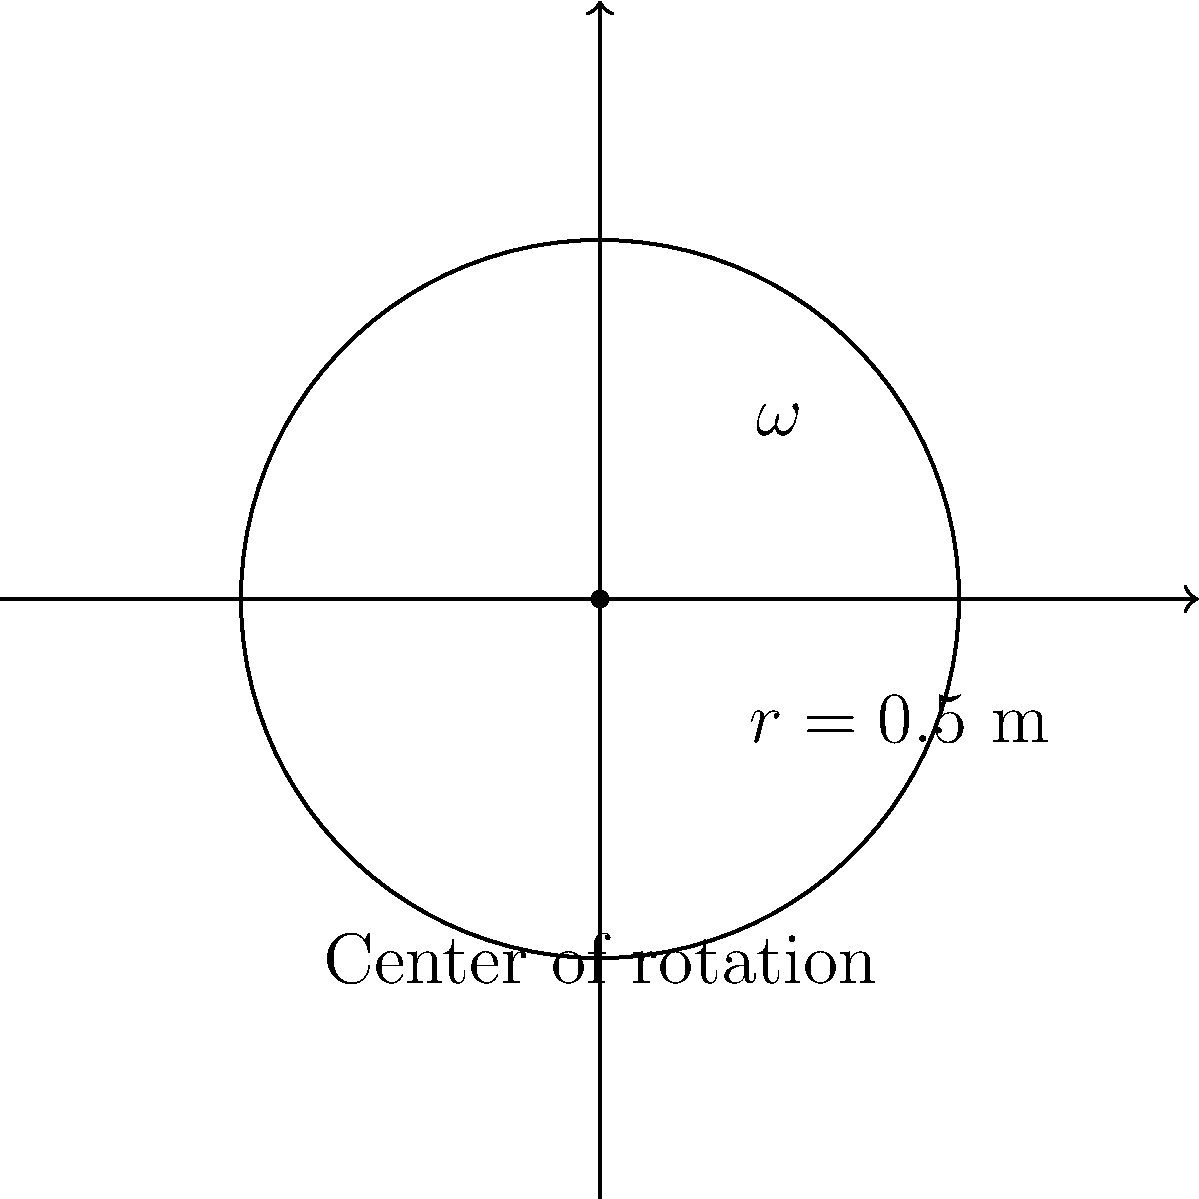As a competitive ice skater preparing for the junior championships, you're analyzing your spin technique. During a practice session, you perform a spin with a radius of 0.5 meters, completing 3 full rotations in 2 seconds. Using the diagram provided, calculate the angular velocity ($\omega$) of your spin in radians per second. To calculate the angular velocity, we'll follow these steps:

1) First, recall the formula for angular velocity:
   $$ \omega = \frac{\Delta \theta}{\Delta t} $$
   where $\Delta \theta$ is the angular displacement and $\Delta t$ is the time taken.

2) We need to determine $\Delta \theta$:
   - One full rotation is $2\pi$ radians
   - You completed 3 full rotations
   - So, $\Delta \theta = 3 \times 2\pi = 6\pi$ radians

3) We're given $\Delta t = 2$ seconds

4) Now, let's substitute these values into our formula:
   $$ \omega = \frac{6\pi \text{ rad}}{2 \text{ s}} = 3\pi \text{ rad/s} $$

5) Simplify:
   $$ \omega = 3\pi \approx 9.42 \text{ rad/s} $$

Therefore, your angular velocity during the spin is $3\pi$ radians per second, or approximately 9.42 rad/s.
Answer: $3\pi$ rad/s 